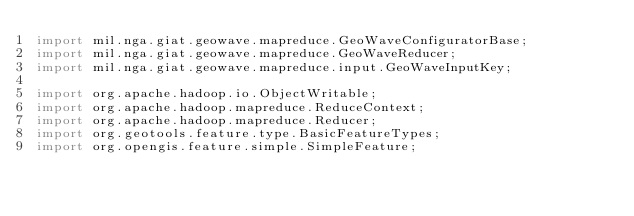Convert code to text. <code><loc_0><loc_0><loc_500><loc_500><_Java_>import mil.nga.giat.geowave.mapreduce.GeoWaveConfiguratorBase;
import mil.nga.giat.geowave.mapreduce.GeoWaveReducer;
import mil.nga.giat.geowave.mapreduce.input.GeoWaveInputKey;

import org.apache.hadoop.io.ObjectWritable;
import org.apache.hadoop.mapreduce.ReduceContext;
import org.apache.hadoop.mapreduce.Reducer;
import org.geotools.feature.type.BasicFeatureTypes;
import org.opengis.feature.simple.SimpleFeature;</code> 